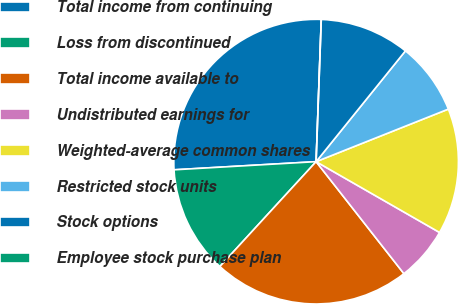<chart> <loc_0><loc_0><loc_500><loc_500><pie_chart><fcel>Total income from continuing<fcel>Loss from discontinued<fcel>Total income available to<fcel>Undistributed earnings for<fcel>Weighted-average common shares<fcel>Restricted stock units<fcel>Stock options<fcel>Employee stock purchase plan<nl><fcel>26.49%<fcel>12.27%<fcel>22.4%<fcel>6.13%<fcel>14.31%<fcel>8.18%<fcel>10.22%<fcel>0.0%<nl></chart> 